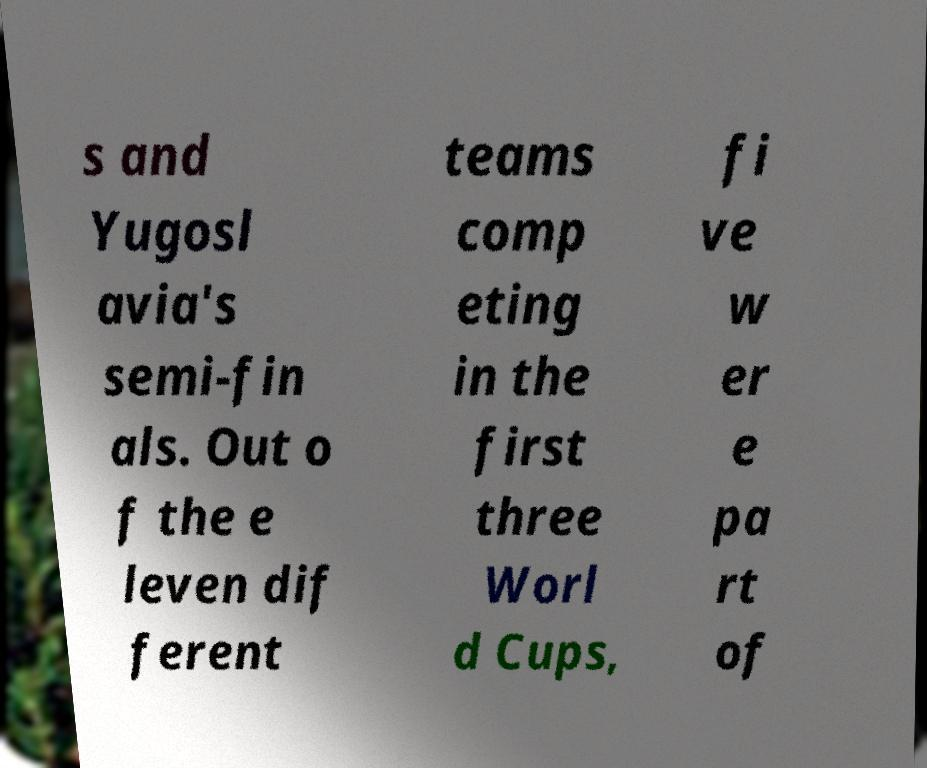Please identify and transcribe the text found in this image. s and Yugosl avia's semi-fin als. Out o f the e leven dif ferent teams comp eting in the first three Worl d Cups, fi ve w er e pa rt of 